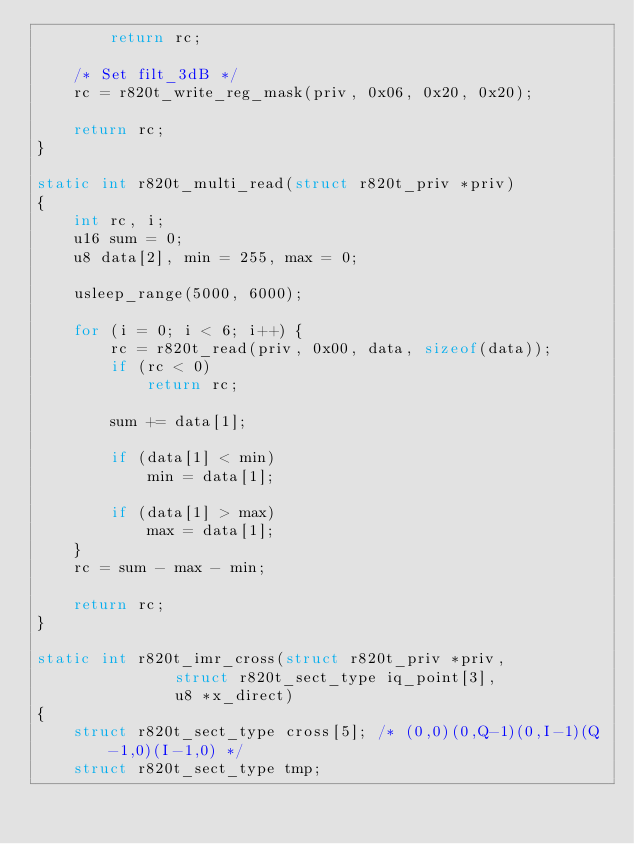Convert code to text. <code><loc_0><loc_0><loc_500><loc_500><_C_>		return rc;

	/* Set filt_3dB */
	rc = r820t_write_reg_mask(priv, 0x06, 0x20, 0x20);

	return rc;
}

static int r820t_multi_read(struct r820t_priv *priv)
{
	int rc, i;
	u16 sum = 0;
	u8 data[2], min = 255, max = 0;

	usleep_range(5000, 6000);

	for (i = 0; i < 6; i++) {
		rc = r820t_read(priv, 0x00, data, sizeof(data));
		if (rc < 0)
			return rc;

		sum += data[1];

		if (data[1] < min)
			min = data[1];

		if (data[1] > max)
			max = data[1];
	}
	rc = sum - max - min;

	return rc;
}

static int r820t_imr_cross(struct r820t_priv *priv,
			   struct r820t_sect_type iq_point[3],
			   u8 *x_direct)
{
	struct r820t_sect_type cross[5]; /* (0,0)(0,Q-1)(0,I-1)(Q-1,0)(I-1,0) */
	struct r820t_sect_type tmp;</code> 